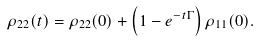Convert formula to latex. <formula><loc_0><loc_0><loc_500><loc_500>\rho _ { 2 2 } ( t ) = \rho _ { 2 2 } ( 0 ) + \left ( 1 - e ^ { - t \Gamma } \right ) \rho _ { 1 1 } ( 0 ) .</formula> 